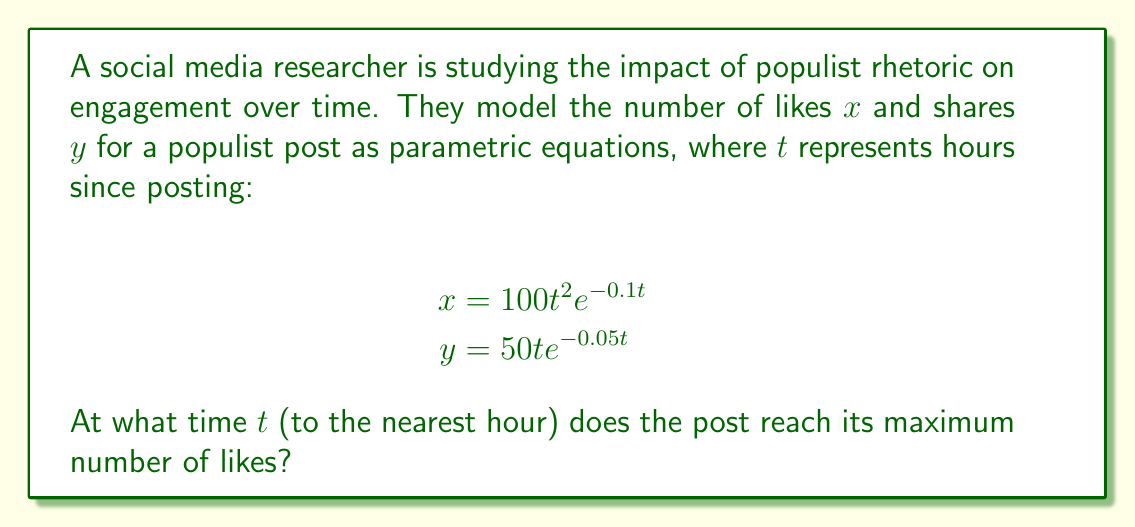What is the answer to this math problem? To find the maximum number of likes, we need to determine when the derivative of $x$ with respect to $t$ equals zero. Let's follow these steps:

1) First, we need to find $\frac{dx}{dt}$ using the product rule:

   $$\frac{dx}{dt} = (100 \cdot 2t \cdot e^{-0.1t}) + (100t^2 \cdot -0.1e^{-0.1t})$$
   $$= 200t e^{-0.1t} - 10t^2 e^{-0.1t}$$
   $$= e^{-0.1t}(200t - 10t^2)$$

2) Set this equal to zero and solve for $t$:

   $$e^{-0.1t}(200t - 10t^2) = 0$$

3) Since $e^{-0.1t}$ is never zero, we can focus on solving:

   $$200t - 10t^2 = 0$$

4) Factor out $10t$:

   $$10t(20 - t) = 0$$

5) Solve this equation:
   Either $t = 0$ or $20 - t = 0$
   So, $t = 0$ or $t = 20$

6) The solution $t = 0$ represents the starting point, not the maximum. Therefore, the maximum occurs at $t = 20$ hours.

To verify this is a maximum and not a minimum, we could take the second derivative and confirm it's negative at $t = 20$, but this isn't necessary for the question asked.
Answer: 20 hours 